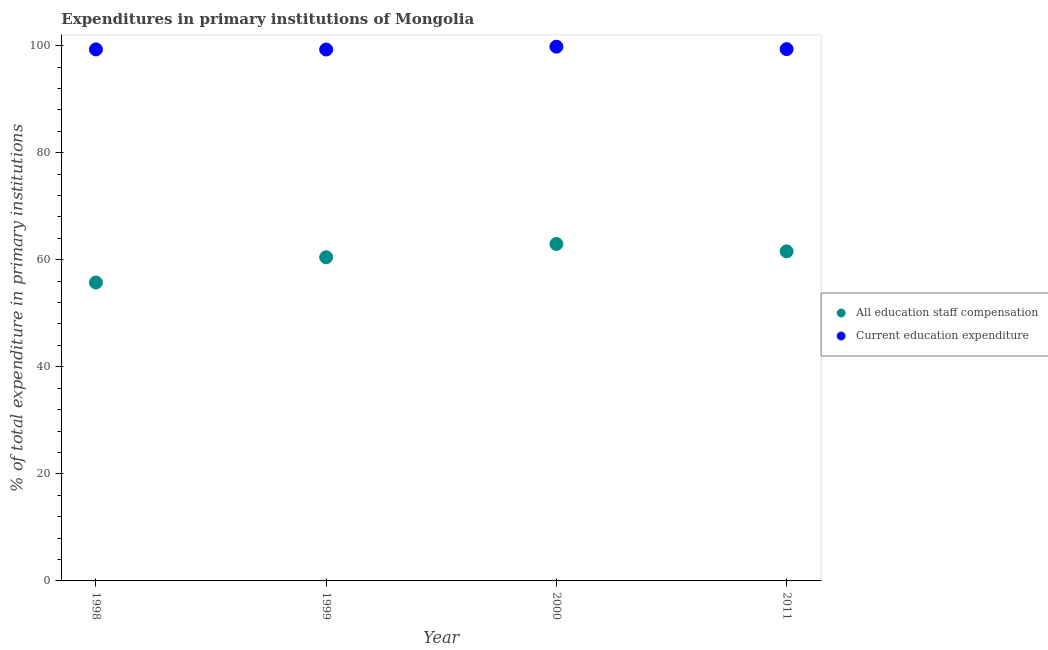How many different coloured dotlines are there?
Keep it short and to the point. 2. What is the expenditure in education in 1998?
Provide a short and direct response. 99.29. Across all years, what is the maximum expenditure in staff compensation?
Offer a terse response. 62.94. Across all years, what is the minimum expenditure in staff compensation?
Keep it short and to the point. 55.74. In which year was the expenditure in staff compensation maximum?
Give a very brief answer. 2000. In which year was the expenditure in staff compensation minimum?
Offer a very short reply. 1998. What is the total expenditure in staff compensation in the graph?
Keep it short and to the point. 240.72. What is the difference between the expenditure in education in 1999 and that in 2000?
Provide a short and direct response. -0.53. What is the difference between the expenditure in staff compensation in 2011 and the expenditure in education in 1999?
Give a very brief answer. -37.7. What is the average expenditure in education per year?
Give a very brief answer. 99.42. In the year 2011, what is the difference between the expenditure in staff compensation and expenditure in education?
Provide a succinct answer. -37.77. What is the ratio of the expenditure in education in 1998 to that in 2000?
Ensure brevity in your answer.  0.99. Is the difference between the expenditure in education in 1998 and 2000 greater than the difference between the expenditure in staff compensation in 1998 and 2000?
Your answer should be very brief. Yes. What is the difference between the highest and the second highest expenditure in staff compensation?
Your answer should be compact. 1.38. What is the difference between the highest and the lowest expenditure in staff compensation?
Your answer should be very brief. 7.2. In how many years, is the expenditure in education greater than the average expenditure in education taken over all years?
Make the answer very short. 1. Is the sum of the expenditure in staff compensation in 1999 and 2011 greater than the maximum expenditure in education across all years?
Keep it short and to the point. Yes. Does the expenditure in education monotonically increase over the years?
Offer a very short reply. No. Is the expenditure in staff compensation strictly greater than the expenditure in education over the years?
Make the answer very short. No. How many dotlines are there?
Keep it short and to the point. 2. How many years are there in the graph?
Provide a short and direct response. 4. What is the difference between two consecutive major ticks on the Y-axis?
Your answer should be compact. 20. How are the legend labels stacked?
Your answer should be compact. Vertical. What is the title of the graph?
Provide a succinct answer. Expenditures in primary institutions of Mongolia. Does "RDB concessional" appear as one of the legend labels in the graph?
Your answer should be compact. No. What is the label or title of the Y-axis?
Keep it short and to the point. % of total expenditure in primary institutions. What is the % of total expenditure in primary institutions in All education staff compensation in 1998?
Ensure brevity in your answer.  55.74. What is the % of total expenditure in primary institutions of Current education expenditure in 1998?
Offer a very short reply. 99.29. What is the % of total expenditure in primary institutions of All education staff compensation in 1999?
Your answer should be compact. 60.46. What is the % of total expenditure in primary institutions of Current education expenditure in 1999?
Keep it short and to the point. 99.27. What is the % of total expenditure in primary institutions in All education staff compensation in 2000?
Your response must be concise. 62.94. What is the % of total expenditure in primary institutions of Current education expenditure in 2000?
Make the answer very short. 99.8. What is the % of total expenditure in primary institutions in All education staff compensation in 2011?
Your response must be concise. 61.57. What is the % of total expenditure in primary institutions in Current education expenditure in 2011?
Keep it short and to the point. 99.34. Across all years, what is the maximum % of total expenditure in primary institutions of All education staff compensation?
Offer a very short reply. 62.94. Across all years, what is the maximum % of total expenditure in primary institutions in Current education expenditure?
Provide a short and direct response. 99.8. Across all years, what is the minimum % of total expenditure in primary institutions of All education staff compensation?
Provide a short and direct response. 55.74. Across all years, what is the minimum % of total expenditure in primary institutions in Current education expenditure?
Offer a very short reply. 99.27. What is the total % of total expenditure in primary institutions in All education staff compensation in the graph?
Your response must be concise. 240.72. What is the total % of total expenditure in primary institutions of Current education expenditure in the graph?
Your answer should be compact. 397.7. What is the difference between the % of total expenditure in primary institutions in All education staff compensation in 1998 and that in 1999?
Ensure brevity in your answer.  -4.72. What is the difference between the % of total expenditure in primary institutions of Current education expenditure in 1998 and that in 1999?
Make the answer very short. 0.02. What is the difference between the % of total expenditure in primary institutions of All education staff compensation in 1998 and that in 2000?
Give a very brief answer. -7.2. What is the difference between the % of total expenditure in primary institutions in Current education expenditure in 1998 and that in 2000?
Give a very brief answer. -0.51. What is the difference between the % of total expenditure in primary institutions in All education staff compensation in 1998 and that in 2011?
Keep it short and to the point. -5.82. What is the difference between the % of total expenditure in primary institutions of Current education expenditure in 1998 and that in 2011?
Offer a terse response. -0.05. What is the difference between the % of total expenditure in primary institutions of All education staff compensation in 1999 and that in 2000?
Your answer should be very brief. -2.48. What is the difference between the % of total expenditure in primary institutions in Current education expenditure in 1999 and that in 2000?
Your answer should be compact. -0.53. What is the difference between the % of total expenditure in primary institutions in All education staff compensation in 1999 and that in 2011?
Make the answer very short. -1.1. What is the difference between the % of total expenditure in primary institutions in Current education expenditure in 1999 and that in 2011?
Give a very brief answer. -0.07. What is the difference between the % of total expenditure in primary institutions of All education staff compensation in 2000 and that in 2011?
Provide a succinct answer. 1.38. What is the difference between the % of total expenditure in primary institutions of Current education expenditure in 2000 and that in 2011?
Your answer should be compact. 0.46. What is the difference between the % of total expenditure in primary institutions of All education staff compensation in 1998 and the % of total expenditure in primary institutions of Current education expenditure in 1999?
Offer a terse response. -43.52. What is the difference between the % of total expenditure in primary institutions in All education staff compensation in 1998 and the % of total expenditure in primary institutions in Current education expenditure in 2000?
Give a very brief answer. -44.06. What is the difference between the % of total expenditure in primary institutions of All education staff compensation in 1998 and the % of total expenditure in primary institutions of Current education expenditure in 2011?
Ensure brevity in your answer.  -43.6. What is the difference between the % of total expenditure in primary institutions of All education staff compensation in 1999 and the % of total expenditure in primary institutions of Current education expenditure in 2000?
Your answer should be compact. -39.34. What is the difference between the % of total expenditure in primary institutions of All education staff compensation in 1999 and the % of total expenditure in primary institutions of Current education expenditure in 2011?
Provide a short and direct response. -38.88. What is the difference between the % of total expenditure in primary institutions of All education staff compensation in 2000 and the % of total expenditure in primary institutions of Current education expenditure in 2011?
Your answer should be very brief. -36.4. What is the average % of total expenditure in primary institutions of All education staff compensation per year?
Your response must be concise. 60.18. What is the average % of total expenditure in primary institutions in Current education expenditure per year?
Make the answer very short. 99.42. In the year 1998, what is the difference between the % of total expenditure in primary institutions of All education staff compensation and % of total expenditure in primary institutions of Current education expenditure?
Your answer should be compact. -43.55. In the year 1999, what is the difference between the % of total expenditure in primary institutions of All education staff compensation and % of total expenditure in primary institutions of Current education expenditure?
Offer a very short reply. -38.81. In the year 2000, what is the difference between the % of total expenditure in primary institutions in All education staff compensation and % of total expenditure in primary institutions in Current education expenditure?
Your answer should be very brief. -36.86. In the year 2011, what is the difference between the % of total expenditure in primary institutions of All education staff compensation and % of total expenditure in primary institutions of Current education expenditure?
Provide a short and direct response. -37.77. What is the ratio of the % of total expenditure in primary institutions of All education staff compensation in 1998 to that in 1999?
Provide a short and direct response. 0.92. What is the ratio of the % of total expenditure in primary institutions of Current education expenditure in 1998 to that in 1999?
Ensure brevity in your answer.  1. What is the ratio of the % of total expenditure in primary institutions in All education staff compensation in 1998 to that in 2000?
Your answer should be very brief. 0.89. What is the ratio of the % of total expenditure in primary institutions of Current education expenditure in 1998 to that in 2000?
Your answer should be very brief. 0.99. What is the ratio of the % of total expenditure in primary institutions of All education staff compensation in 1998 to that in 2011?
Offer a terse response. 0.91. What is the ratio of the % of total expenditure in primary institutions in Current education expenditure in 1998 to that in 2011?
Offer a very short reply. 1. What is the ratio of the % of total expenditure in primary institutions in All education staff compensation in 1999 to that in 2000?
Provide a short and direct response. 0.96. What is the ratio of the % of total expenditure in primary institutions in Current education expenditure in 1999 to that in 2000?
Offer a terse response. 0.99. What is the ratio of the % of total expenditure in primary institutions of All education staff compensation in 1999 to that in 2011?
Provide a short and direct response. 0.98. What is the ratio of the % of total expenditure in primary institutions of Current education expenditure in 1999 to that in 2011?
Offer a terse response. 1. What is the ratio of the % of total expenditure in primary institutions of All education staff compensation in 2000 to that in 2011?
Your answer should be compact. 1.02. What is the ratio of the % of total expenditure in primary institutions in Current education expenditure in 2000 to that in 2011?
Your response must be concise. 1. What is the difference between the highest and the second highest % of total expenditure in primary institutions of All education staff compensation?
Give a very brief answer. 1.38. What is the difference between the highest and the second highest % of total expenditure in primary institutions of Current education expenditure?
Your answer should be compact. 0.46. What is the difference between the highest and the lowest % of total expenditure in primary institutions in All education staff compensation?
Ensure brevity in your answer.  7.2. What is the difference between the highest and the lowest % of total expenditure in primary institutions in Current education expenditure?
Offer a terse response. 0.53. 